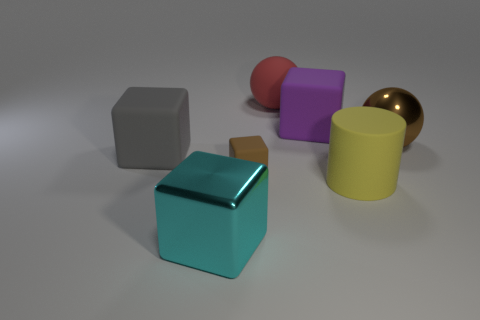There is another object that is the same color as the small matte object; what size is it?
Your response must be concise. Large. The gray matte thing is what shape?
Keep it short and to the point. Cube. What number of brown spheres have the same material as the gray object?
Ensure brevity in your answer.  0. What is the color of the small thing that is made of the same material as the big gray cube?
Make the answer very short. Brown. There is a purple block; is it the same size as the thing that is on the right side of the matte cylinder?
Offer a terse response. Yes. What material is the block in front of the brown object in front of the big thing on the left side of the big cyan metal block?
Give a very brief answer. Metal. How many things are either big spheres or big gray balls?
Provide a short and direct response. 2. There is a shiny object on the right side of the cyan metallic thing; does it have the same color as the thing that is in front of the big yellow rubber object?
Ensure brevity in your answer.  No. There is a red matte object that is the same size as the yellow rubber cylinder; what is its shape?
Your answer should be compact. Sphere. How many things are either large objects that are behind the cyan object or shiny objects in front of the brown cube?
Keep it short and to the point. 6. 